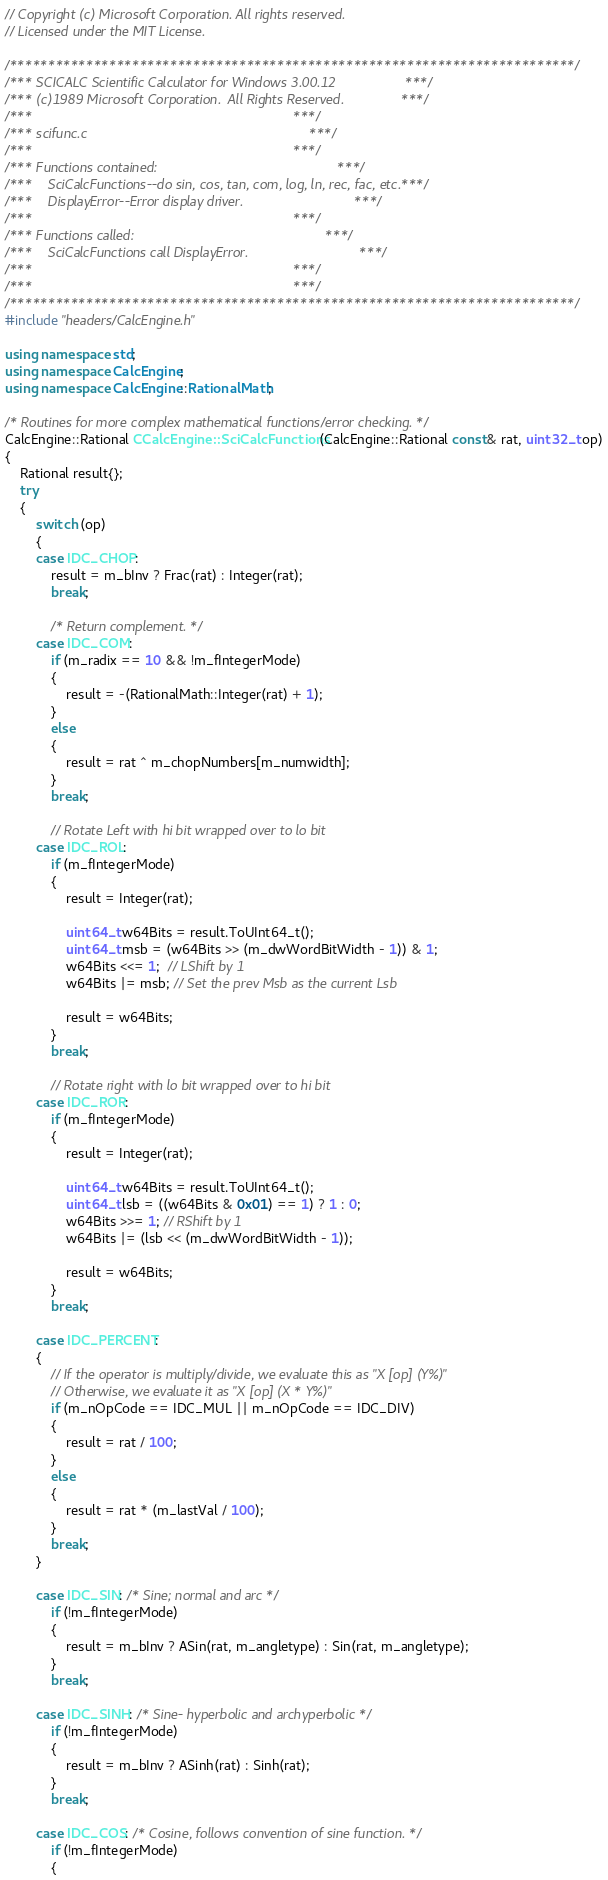<code> <loc_0><loc_0><loc_500><loc_500><_C++_>// Copyright (c) Microsoft Corporation. All rights reserved.
// Licensed under the MIT License.

/**************************************************************************/
/*** SCICALC Scientific Calculator for Windows 3.00.12                  ***/
/*** (c)1989 Microsoft Corporation.  All Rights Reserved.               ***/
/***                                                                    ***/
/*** scifunc.c                                                          ***/
/***                                                                    ***/
/*** Functions contained:                                               ***/
/***    SciCalcFunctions--do sin, cos, tan, com, log, ln, rec, fac, etc.***/
/***    DisplayError--Error display driver.                             ***/
/***                                                                    ***/
/*** Functions called:                                                  ***/
/***    SciCalcFunctions call DisplayError.                             ***/
/***                                                                    ***/
/***                                                                    ***/
/**************************************************************************/
#include "headers/CalcEngine.h"

using namespace std;
using namespace CalcEngine;
using namespace CalcEngine::RationalMath;

/* Routines for more complex mathematical functions/error checking. */
CalcEngine::Rational CCalcEngine::SciCalcFunctions(CalcEngine::Rational const& rat, uint32_t op)
{
    Rational result{};
    try
    {
        switch (op)
        {
        case IDC_CHOP:
            result = m_bInv ? Frac(rat) : Integer(rat);
            break;

            /* Return complement. */
        case IDC_COM:
            if (m_radix == 10 && !m_fIntegerMode)
            {
                result = -(RationalMath::Integer(rat) + 1);
            }
            else
            {
                result = rat ^ m_chopNumbers[m_numwidth];
            }
            break;

            // Rotate Left with hi bit wrapped over to lo bit
        case IDC_ROL:
            if (m_fIntegerMode)
            {
                result = Integer(rat);

                uint64_t w64Bits = result.ToUInt64_t();
                uint64_t msb = (w64Bits >> (m_dwWordBitWidth - 1)) & 1;
                w64Bits <<= 1;  // LShift by 1
                w64Bits |= msb; // Set the prev Msb as the current Lsb

                result = w64Bits;
            }
            break;

            // Rotate right with lo bit wrapped over to hi bit
        case IDC_ROR:
            if (m_fIntegerMode)
            {
                result = Integer(rat);

                uint64_t w64Bits = result.ToUInt64_t();
                uint64_t lsb = ((w64Bits & 0x01) == 1) ? 1 : 0;
                w64Bits >>= 1; // RShift by 1
                w64Bits |= (lsb << (m_dwWordBitWidth - 1));

                result = w64Bits;
            }
            break;

        case IDC_PERCENT:
        {
            // If the operator is multiply/divide, we evaluate this as "X [op] (Y%)"
            // Otherwise, we evaluate it as "X [op] (X * Y%)"
            if (m_nOpCode == IDC_MUL || m_nOpCode == IDC_DIV)
            {
                result = rat / 100;
            }
            else
            {
                result = rat * (m_lastVal / 100);
            }
            break;
        }

        case IDC_SIN: /* Sine; normal and arc */
            if (!m_fIntegerMode)
            {
                result = m_bInv ? ASin(rat, m_angletype) : Sin(rat, m_angletype);
            }
            break;

        case IDC_SINH: /* Sine- hyperbolic and archyperbolic */
            if (!m_fIntegerMode)
            {
                result = m_bInv ? ASinh(rat) : Sinh(rat);
            }
            break;

        case IDC_COS: /* Cosine, follows convention of sine function. */
            if (!m_fIntegerMode)
            {</code> 